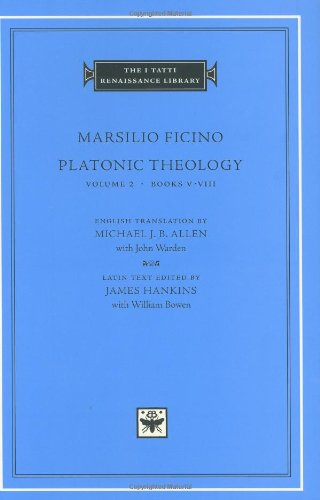Can you describe the visual elements on the cover of the book? The cover features a minimalistic and elegant design with a central emblem that symbolizes the philosophical depth of the content. The use of a serene blue color and classic typography conveys the scholarly nature of this Renaissance text. 